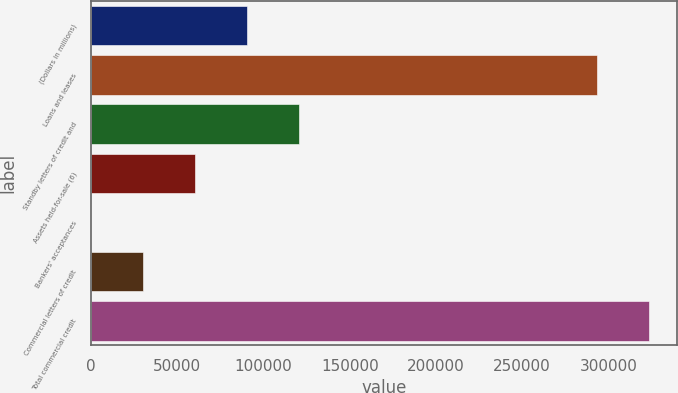<chart> <loc_0><loc_0><loc_500><loc_500><bar_chart><fcel>(Dollars in millions)<fcel>Loans and leases<fcel>Standby letters of credit and<fcel>Assets held-for-sale (6)<fcel>Bankers' acceptances<fcel>Commercial letters of credit<fcel>Total commercial credit<nl><fcel>90279.1<fcel>293519<fcel>120367<fcel>60191.4<fcel>16<fcel>30103.7<fcel>323607<nl></chart> 